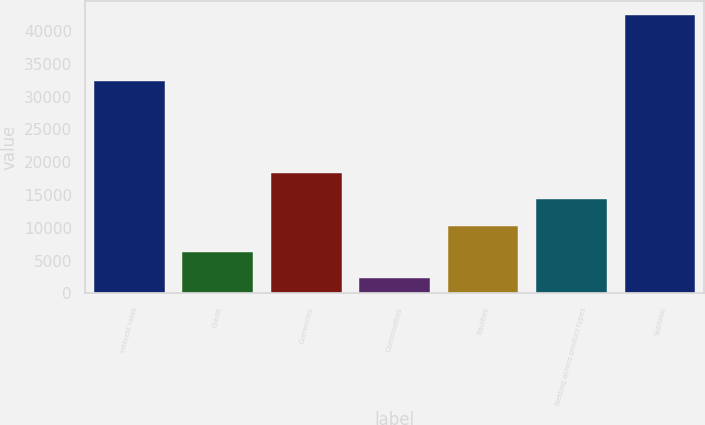Convert chart. <chart><loc_0><loc_0><loc_500><loc_500><bar_chart><fcel>Interest rates<fcel>Credit<fcel>Currencies<fcel>Commodities<fcel>Equities<fcel>Netting across product types<fcel>Subtotal<nl><fcel>32422<fcel>6289.7<fcel>18357.8<fcel>2267<fcel>10312.4<fcel>14335.1<fcel>42494<nl></chart> 